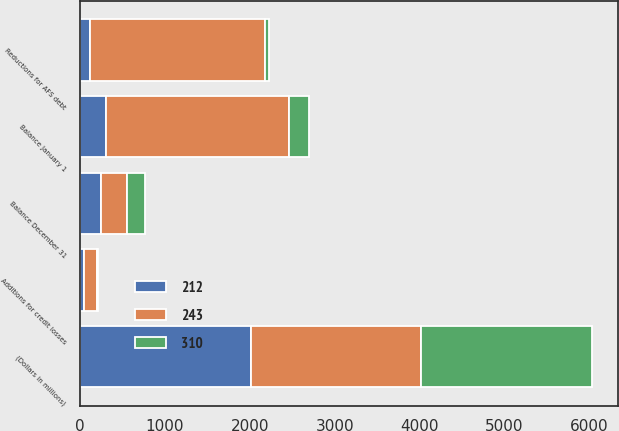Convert chart. <chart><loc_0><loc_0><loc_500><loc_500><stacked_bar_chart><ecel><fcel>(Dollars in millions)<fcel>Balance January 1<fcel>Additions for credit losses<fcel>Reductions for AFS debt<fcel>Balance December 31<nl><fcel>310<fcel>2013<fcel>243<fcel>14<fcel>51<fcel>212<nl><fcel>212<fcel>2012<fcel>310<fcel>46<fcel>120<fcel>243<nl><fcel>243<fcel>2011<fcel>2148<fcel>149<fcel>2059<fcel>310<nl></chart> 